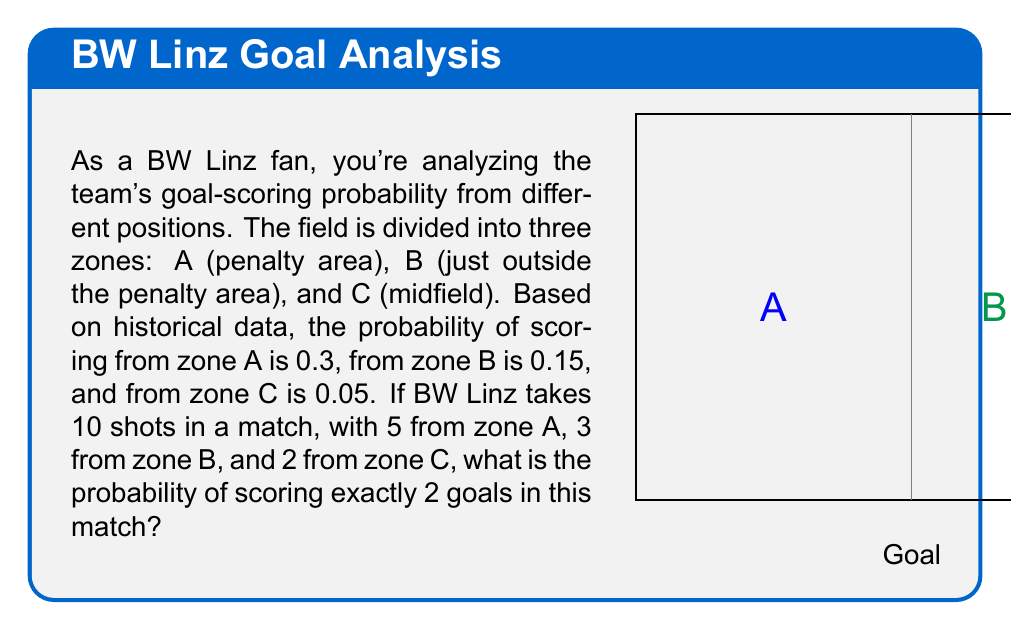Help me with this question. Let's approach this step-by-step using the binomial probability formula:

1) We need to calculate the probability of scoring exactly 2 goals out of 10 shots, where each shot has a different probability based on its zone.

2) This scenario follows a Poisson binomial distribution, which is a generalization of the binomial distribution where each trial has a different probability of success.

3) To simplify, let's calculate the average probability of scoring for any given shot:

   $p_{avg} = \frac{5 \cdot 0.3 + 3 \cdot 0.15 + 2 \cdot 0.05}{10} = 0.205$

4) Now we can use the binomial probability formula with this average probability:

   $P(X = k) = \binom{n}{k} p^k (1-p)^{n-k}$

   Where:
   $n = 10$ (total shots)
   $k = 2$ (goals we want to score)
   $p = 0.205$ (average probability of scoring)

5) Plugging in the values:

   $P(X = 2) = \binom{10}{2} (0.205)^2 (1-0.205)^{8}$

6) Calculating:
   
   $P(X = 2) = 45 \cdot 0.042025 \cdot 0.1327323 \approx 0.2508$

Therefore, the probability of scoring exactly 2 goals is approximately 0.2508 or 25.08%.
Answer: $0.2508$ or $25.08\%$ 